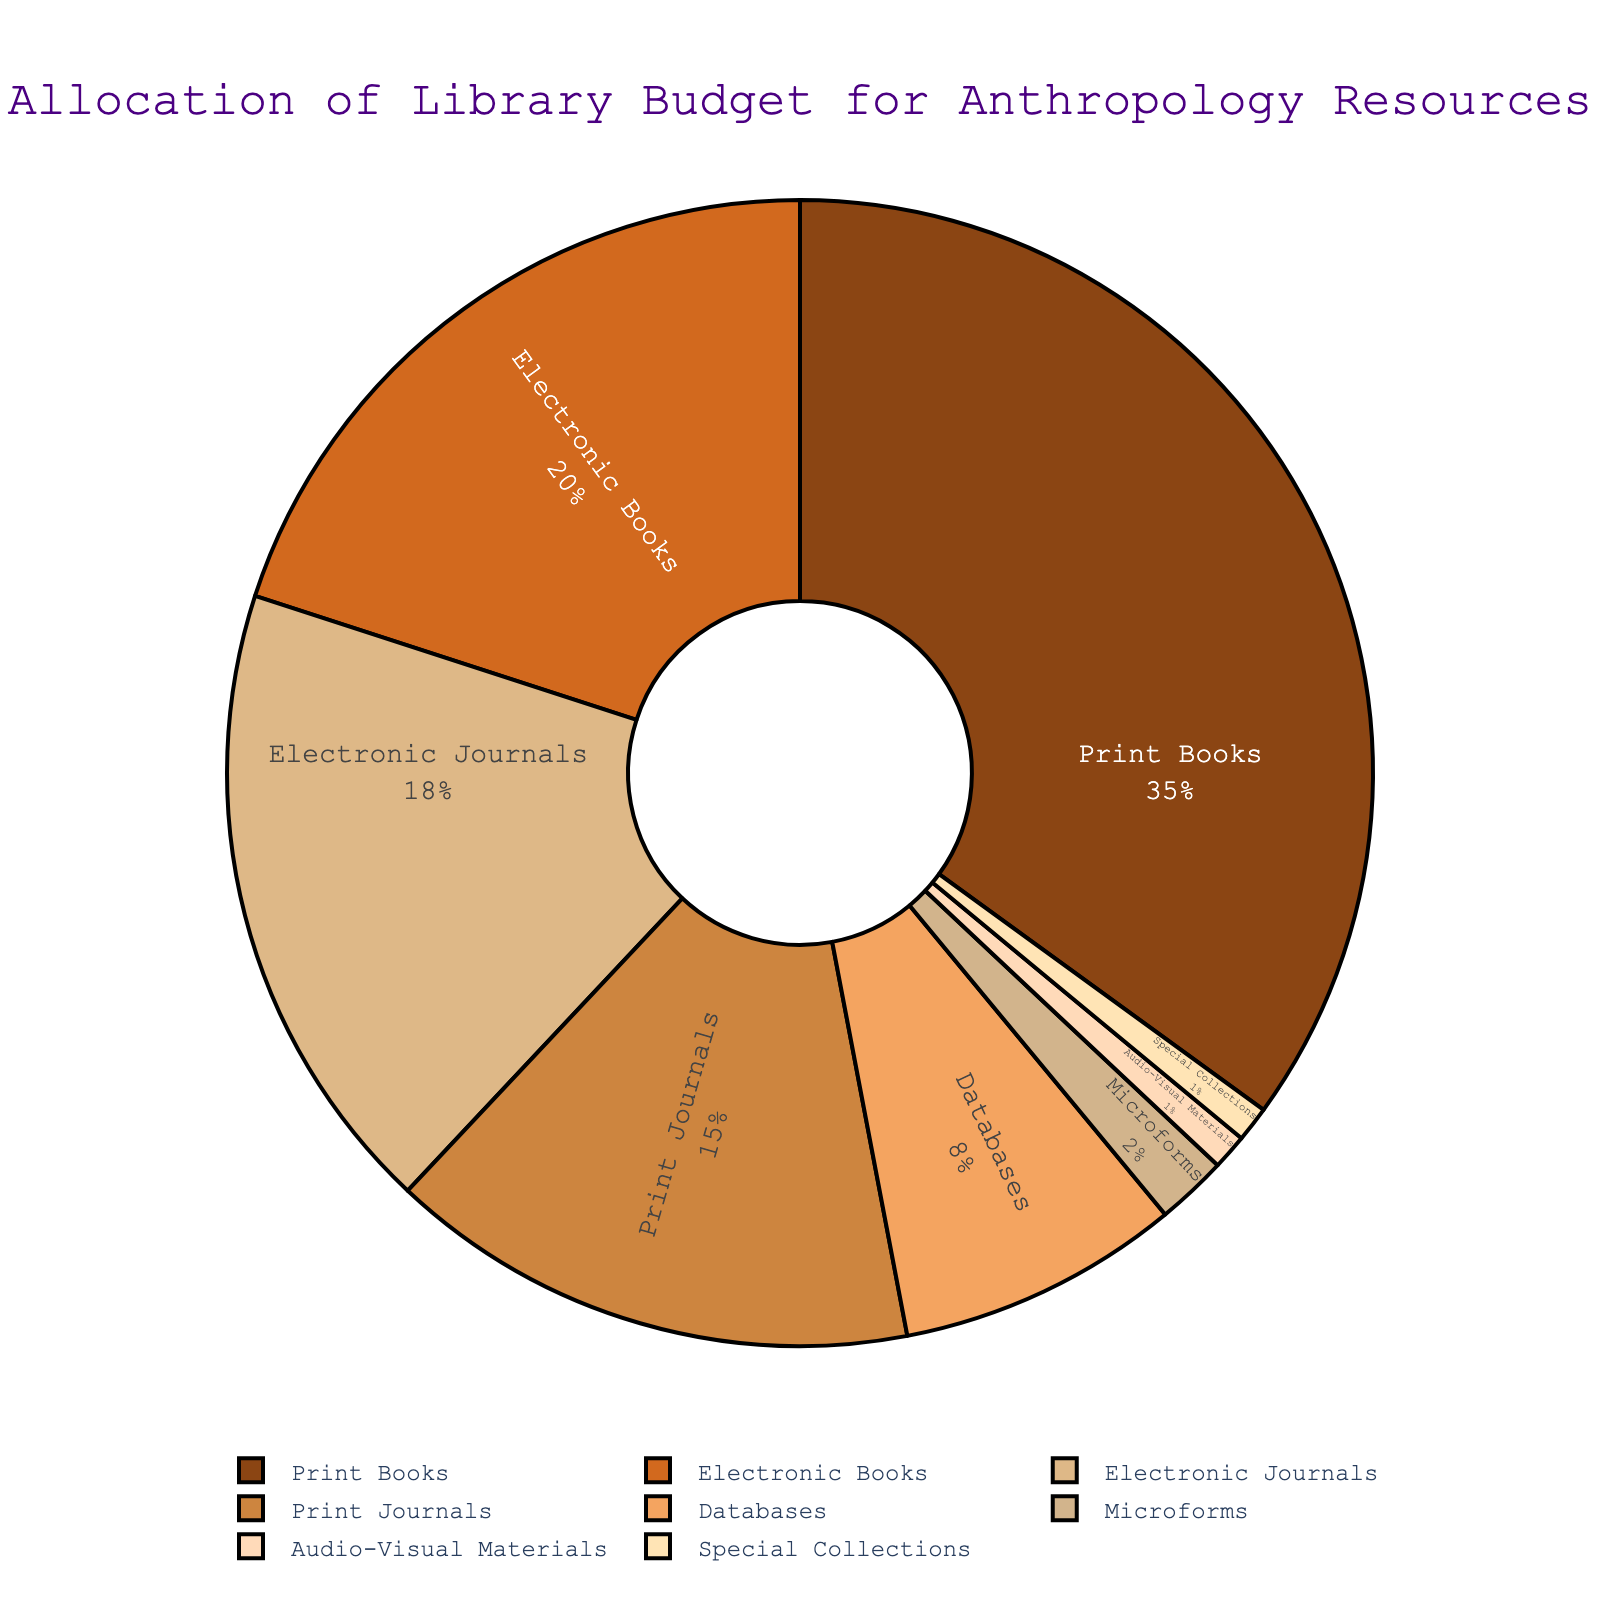What percentage of the library budget is allocated to digital resources (Electronic Books + Electronic Journals + Databases)? Electronic Books (20%) + Electronic Journals (18%) + Databases (8%) = 46%. So, the total budget allocated to digital resources is 46%.
Answer: 46% Which format has the highest allocation in the library budget? Print Books have the highest allocation at 35%. The figure shows that the largest segment of the pie chart represents print books.
Answer: Print Books What is the combined budget percentage for Print Journals and Microforms? Print Journals (15%) + Microforms (2%) = 17%. To get the combined budget percentage, simply add the percentages of Print Journals and Microforms.
Answer: 17% Which allocation is smaller, Audio-Visual Materials or Special Collections? Both Audio-Visual Materials and Special Collections have a 1% allocation each. By examining the pie chart, these two segments are visually equal in size.
Answer: They are equal By how much does the allocation for Electronic Books differ from Print Journals? Electronic Books (20%) - Print Journals (15%) = 5%. To find the difference, subtract the percentage of Print Journals from Electronic Books.
Answer: 5% What is the total allocation percentage for non-print materials (Electronic Books + Electronic Journals + Databases + Audio-Visual Materials + Special Collections)? Electronic Books (20%) + Electronic Journals (18%) + Databases (8%) + Audio-Visual Materials (1%) + Special Collections (1%) = 48%. Sum all the percentages for non-print materials to get the total allocation.
Answer: 48% Which color corresponds to the segment representing Print Books in the pie chart? The Print Books segment is represented by a brown shade. By inspecting the colors referenced in the visual, the largest brown segment corresponds to Print Books.
Answer: Brown 